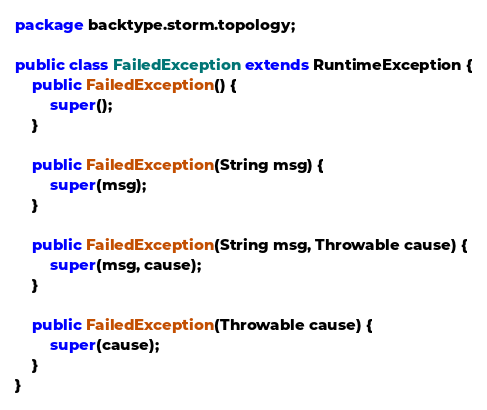Convert code to text. <code><loc_0><loc_0><loc_500><loc_500><_Java_>package backtype.storm.topology;

public class FailedException extends RuntimeException {
	public FailedException() {
		super();
	}

	public FailedException(String msg) {
		super(msg);
	}

	public FailedException(String msg, Throwable cause) {
		super(msg, cause);
	}

	public FailedException(Throwable cause) {
		super(cause);
	}
}
</code> 